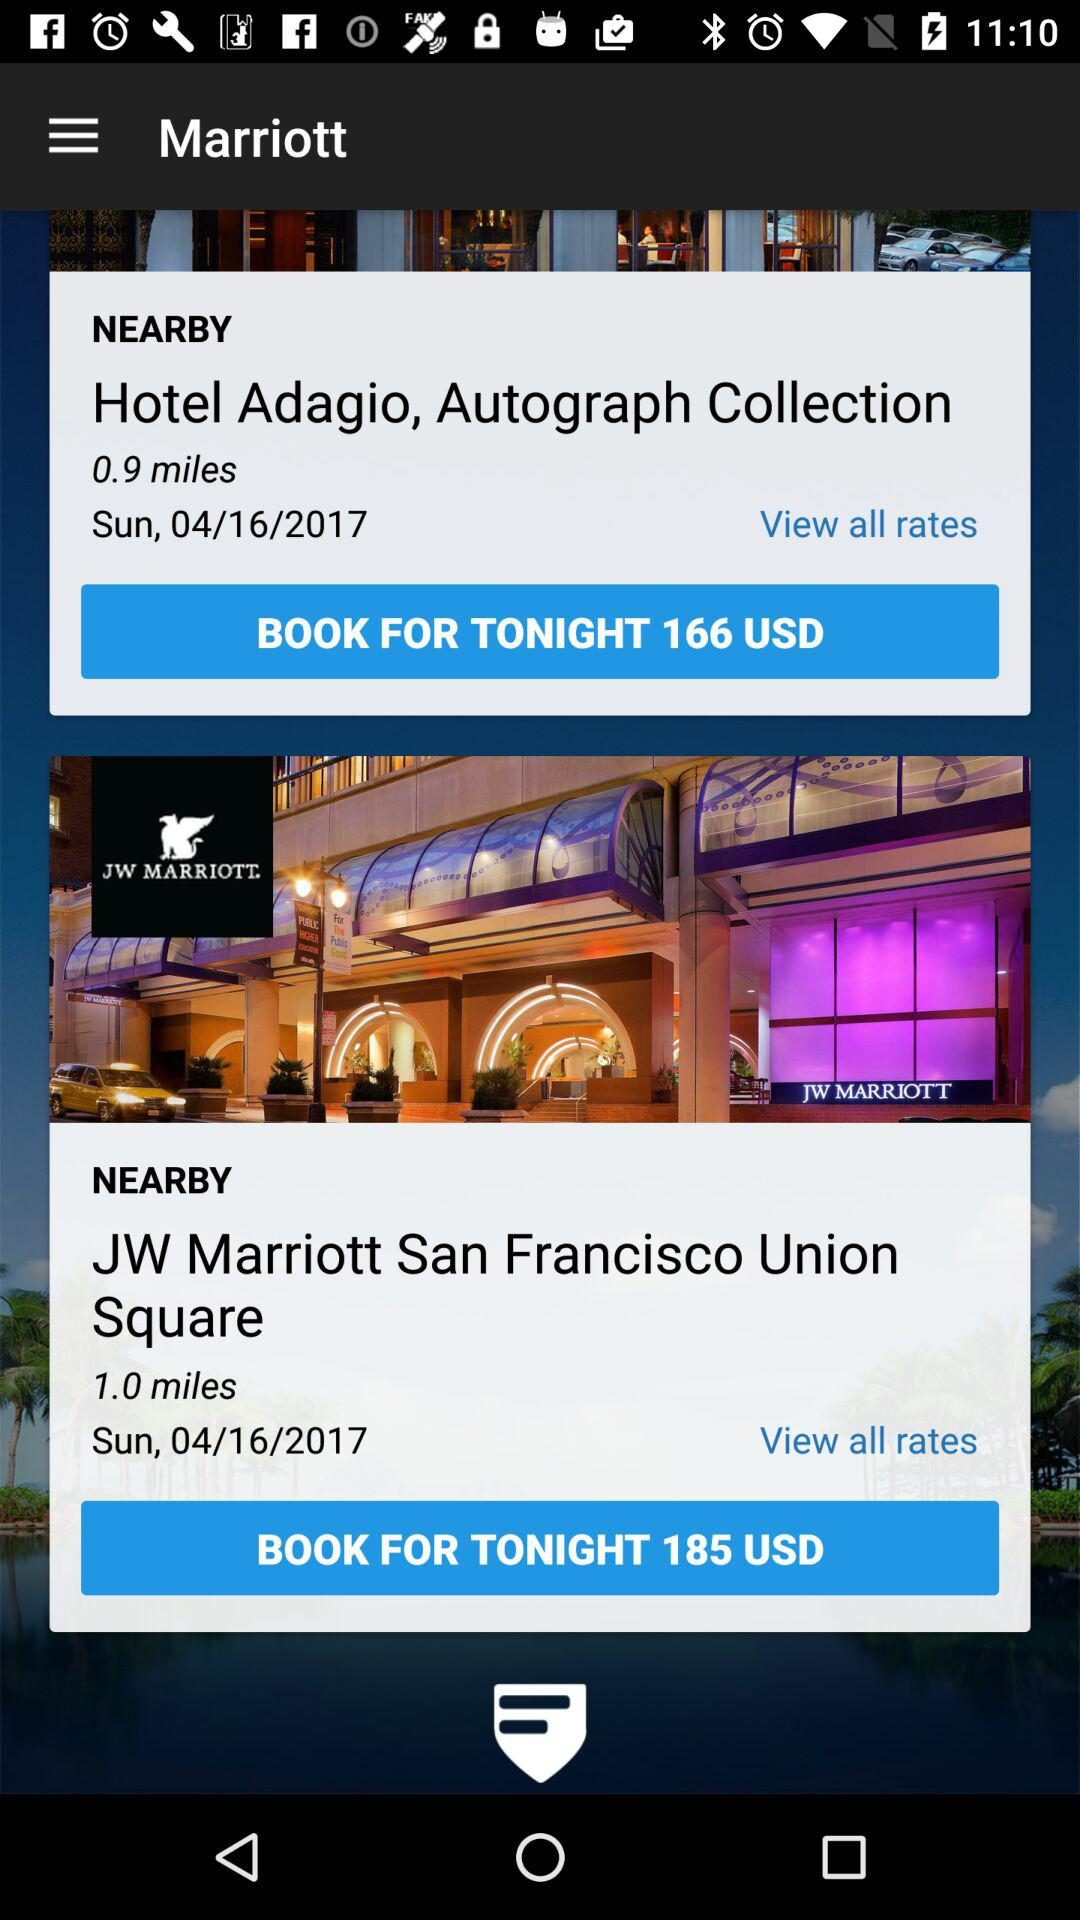How much more does the JW Marriott San Francisco Union Square cost than the Hotel Adagio, Autograph Collection?
Answer the question using a single word or phrase. 19 USD 